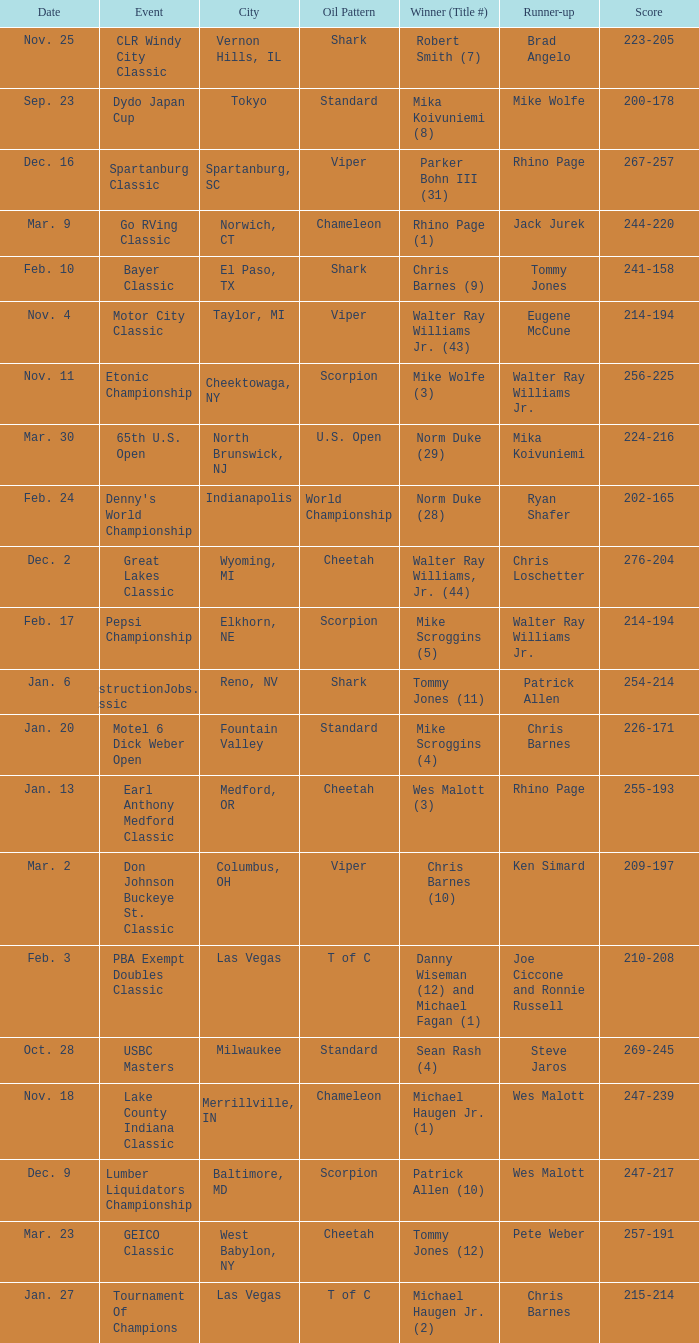Parse the full table. {'header': ['Date', 'Event', 'City', 'Oil Pattern', 'Winner (Title #)', 'Runner-up', 'Score'], 'rows': [['Nov. 25', 'CLR Windy City Classic', 'Vernon Hills, IL', 'Shark', 'Robert Smith (7)', 'Brad Angelo', '223-205'], ['Sep. 23', 'Dydo Japan Cup', 'Tokyo', 'Standard', 'Mika Koivuniemi (8)', 'Mike Wolfe', '200-178'], ['Dec. 16', 'Spartanburg Classic', 'Spartanburg, SC', 'Viper', 'Parker Bohn III (31)', 'Rhino Page', '267-257'], ['Mar. 9', 'Go RVing Classic', 'Norwich, CT', 'Chameleon', 'Rhino Page (1)', 'Jack Jurek', '244-220'], ['Feb. 10', 'Bayer Classic', 'El Paso, TX', 'Shark', 'Chris Barnes (9)', 'Tommy Jones', '241-158'], ['Nov. 4', 'Motor City Classic', 'Taylor, MI', 'Viper', 'Walter Ray Williams Jr. (43)', 'Eugene McCune', '214-194'], ['Nov. 11', 'Etonic Championship', 'Cheektowaga, NY', 'Scorpion', 'Mike Wolfe (3)', 'Walter Ray Williams Jr.', '256-225'], ['Mar. 30', '65th U.S. Open', 'North Brunswick, NJ', 'U.S. Open', 'Norm Duke (29)', 'Mika Koivuniemi', '224-216'], ['Feb. 24', "Denny's World Championship", 'Indianapolis', 'World Championship', 'Norm Duke (28)', 'Ryan Shafer', '202-165'], ['Dec. 2', 'Great Lakes Classic', 'Wyoming, MI', 'Cheetah', 'Walter Ray Williams, Jr. (44)', 'Chris Loschetter', '276-204'], ['Feb. 17', 'Pepsi Championship', 'Elkhorn, NE', 'Scorpion', 'Mike Scroggins (5)', 'Walter Ray Williams Jr.', '214-194'], ['Jan. 6', 'ConstructionJobs.com Classic', 'Reno, NV', 'Shark', 'Tommy Jones (11)', 'Patrick Allen', '254-214'], ['Jan. 20', 'Motel 6 Dick Weber Open', 'Fountain Valley', 'Standard', 'Mike Scroggins (4)', 'Chris Barnes', '226-171'], ['Jan. 13', 'Earl Anthony Medford Classic', 'Medford, OR', 'Cheetah', 'Wes Malott (3)', 'Rhino Page', '255-193'], ['Mar. 2', 'Don Johnson Buckeye St. Classic', 'Columbus, OH', 'Viper', 'Chris Barnes (10)', 'Ken Simard', '209-197'], ['Feb. 3', 'PBA Exempt Doubles Classic', 'Las Vegas', 'T of C', 'Danny Wiseman (12) and Michael Fagan (1)', 'Joe Ciccone and Ronnie Russell', '210-208'], ['Oct. 28', 'USBC Masters', 'Milwaukee', 'Standard', 'Sean Rash (4)', 'Steve Jaros', '269-245'], ['Nov. 18', 'Lake County Indiana Classic', 'Merrillville, IN', 'Chameleon', 'Michael Haugen Jr. (1)', 'Wes Malott', '247-239'], ['Dec. 9', 'Lumber Liquidators Championship', 'Baltimore, MD', 'Scorpion', 'Patrick Allen (10)', 'Wes Malott', '247-217'], ['Mar. 23', 'GEICO Classic', 'West Babylon, NY', 'Cheetah', 'Tommy Jones (12)', 'Pete Weber', '257-191'], ['Jan. 27', 'Tournament Of Champions', 'Las Vegas', 'T of C', 'Michael Haugen Jr. (2)', 'Chris Barnes', '215-214']]} Name the Date when has  robert smith (7)? Nov. 25. 